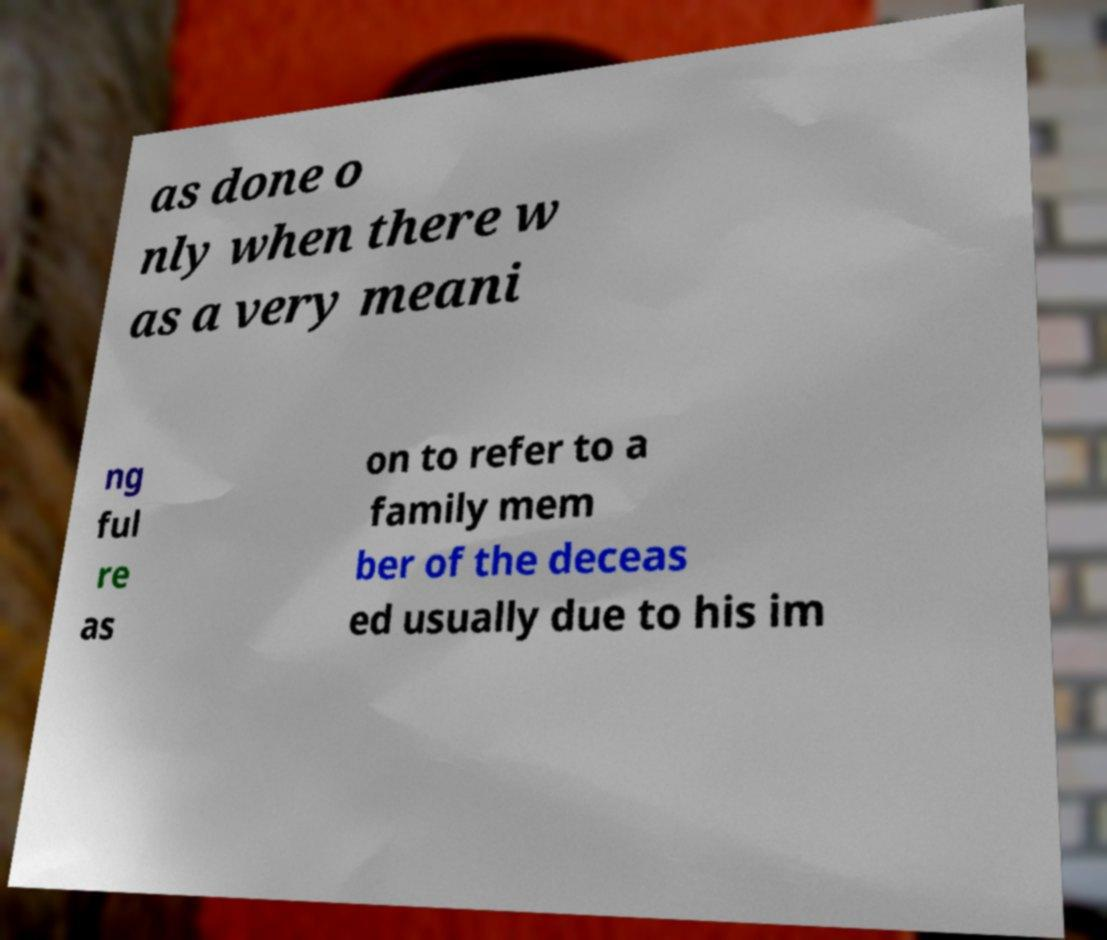Could you assist in decoding the text presented in this image and type it out clearly? as done o nly when there w as a very meani ng ful re as on to refer to a family mem ber of the deceas ed usually due to his im 